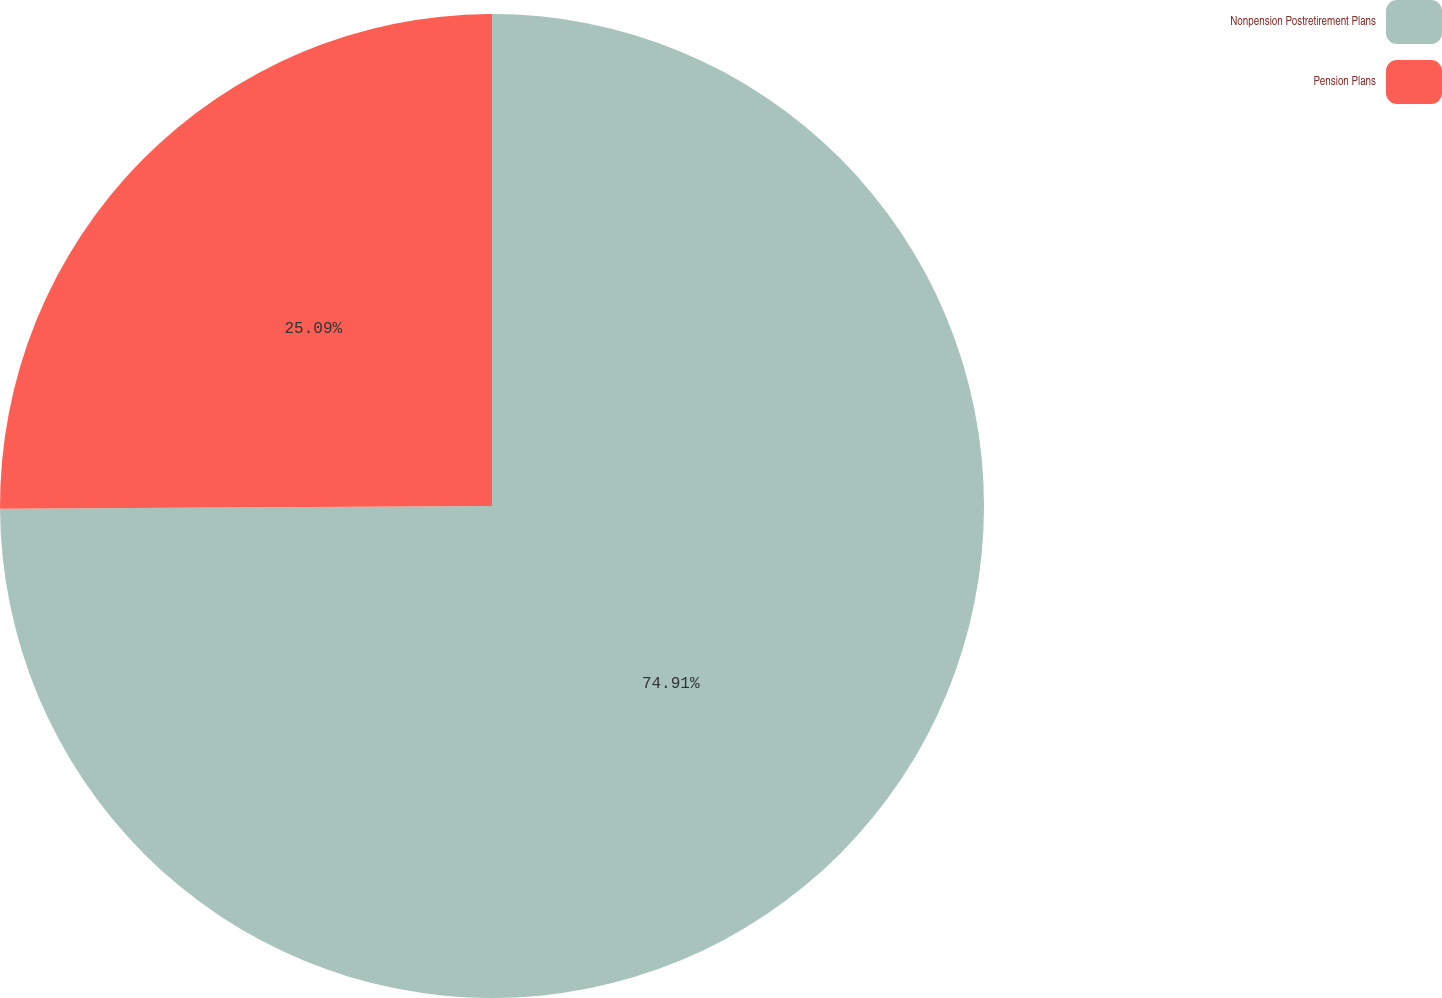Convert chart to OTSL. <chart><loc_0><loc_0><loc_500><loc_500><pie_chart><fcel>Nonpension Postretirement Plans<fcel>Pension Plans<nl><fcel>74.91%<fcel>25.09%<nl></chart> 